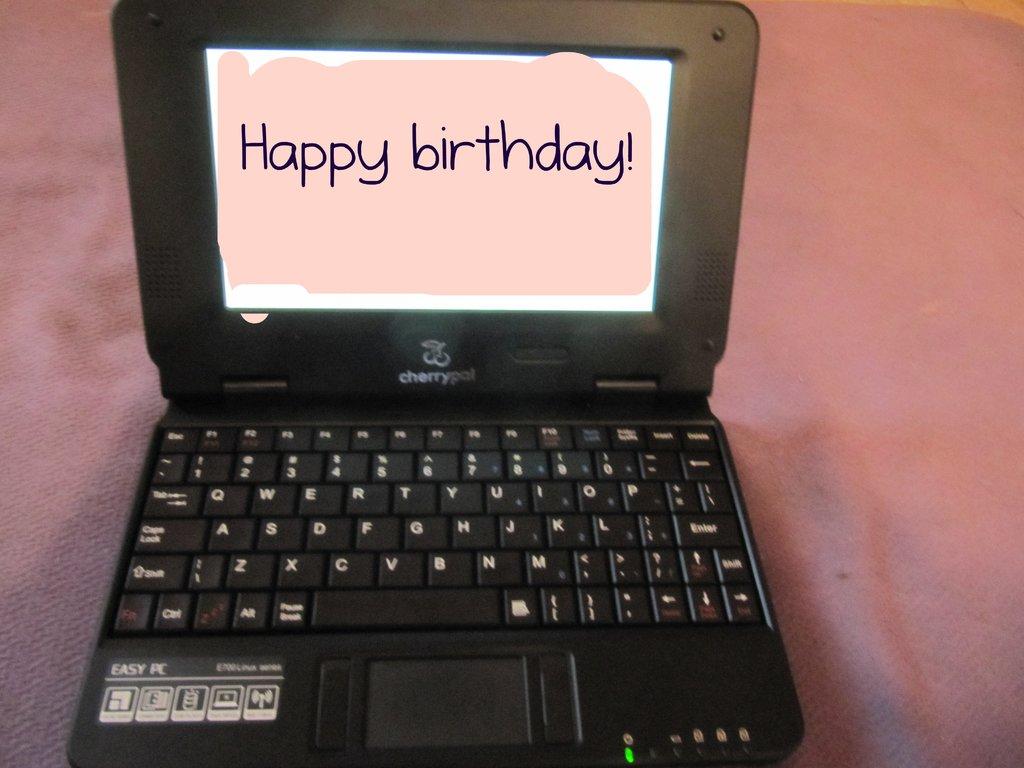What greeting is the device featuring?
Offer a very short reply. Happy birthday. What is the laptop brand?
Make the answer very short. Cherrypal. 